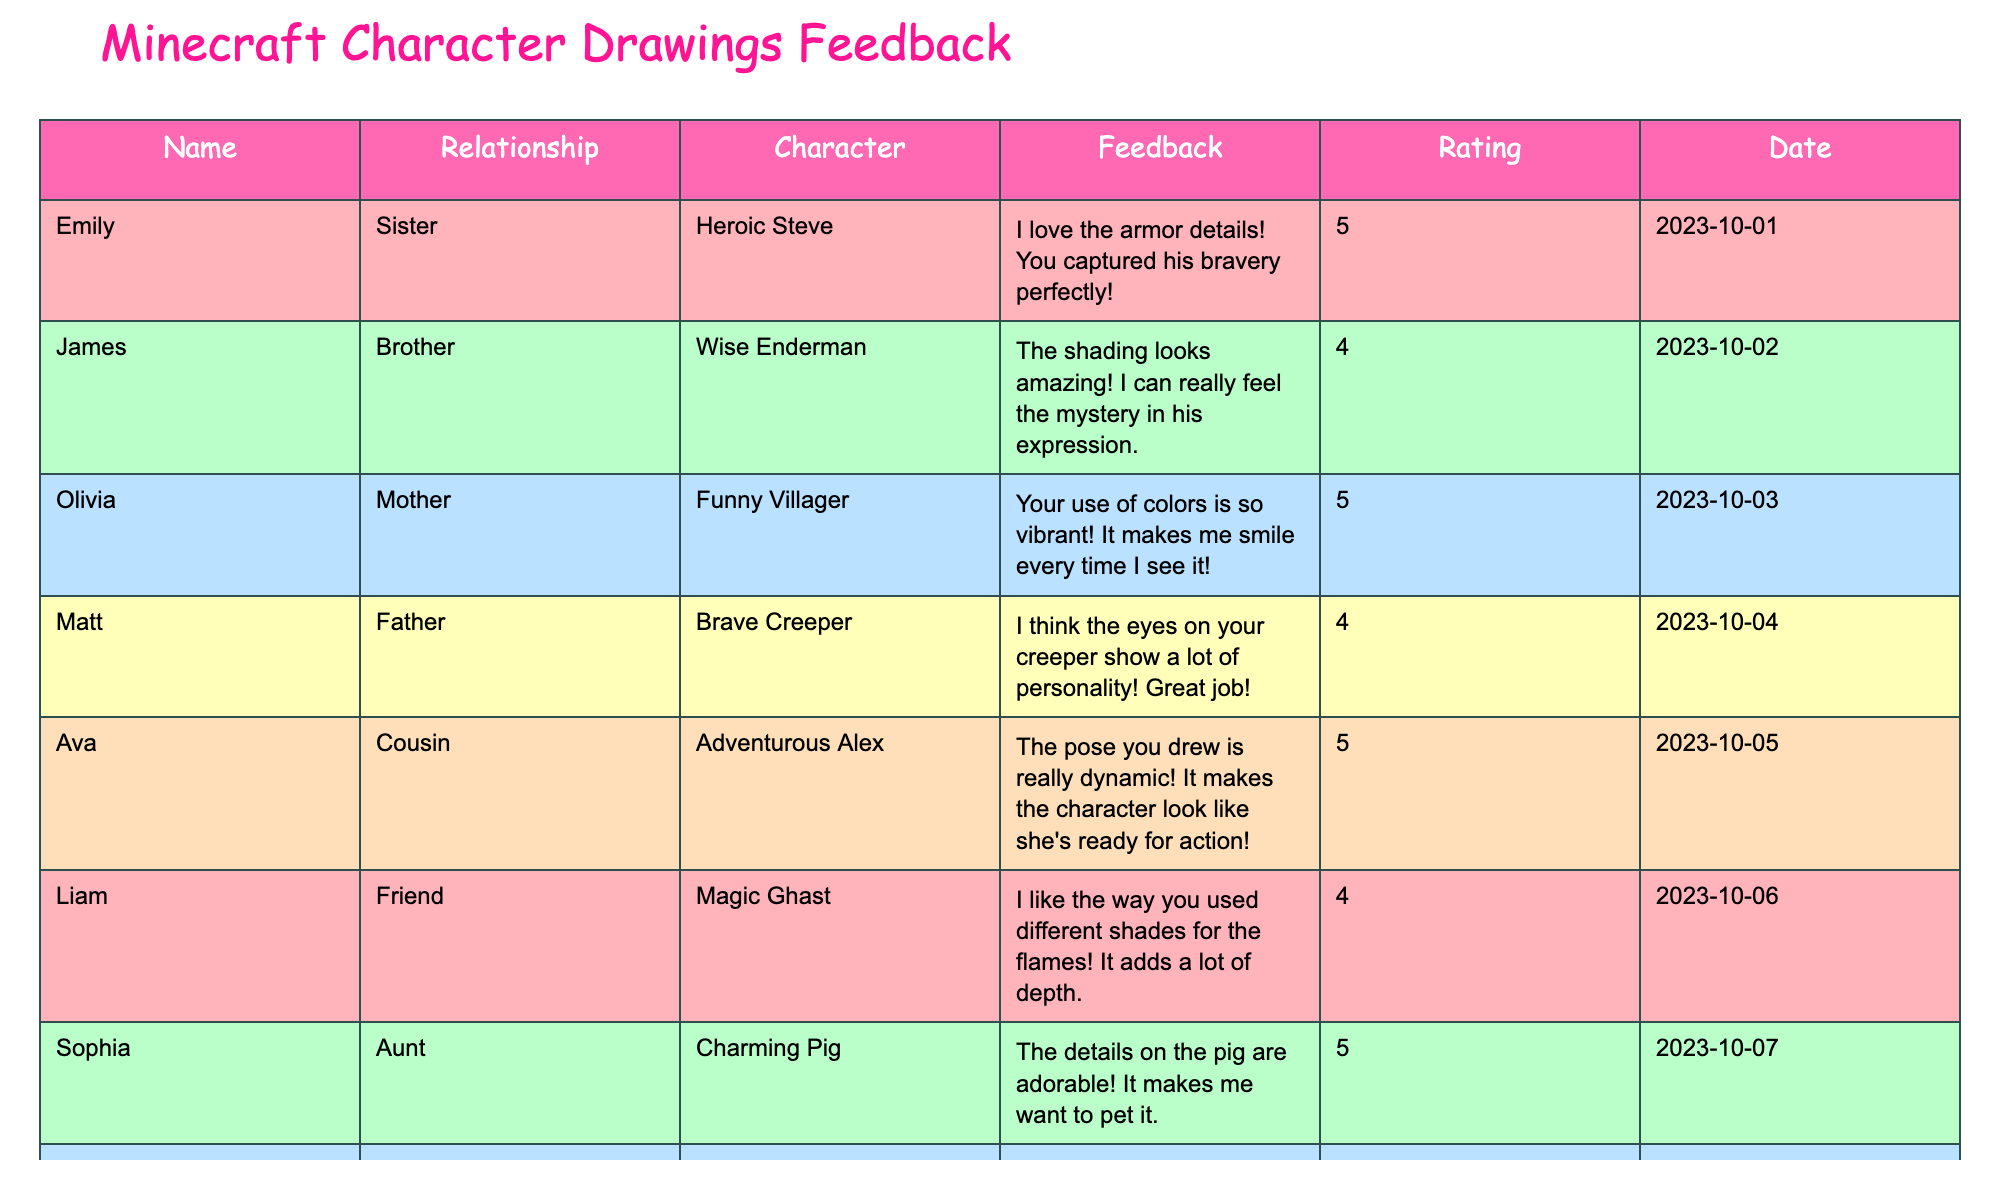What's the highest rating given for a character drawing? The ratings in the table show that "Heroic Steve," "Funny Villager," "Adventurous Alex," "Charming Pig," "Fast Skeleton," and "Playful Fox" all received the highest rating of 5.
Answer: 5 Who gave feedback for the character "Magic Ghast"? Looking through the table, it shows that Liam, a friend, provided feedback for the character "Magic Ghast."
Answer: Liam What is the average rating of all the character drawings? To find the average, add up all the ratings (5 + 4 + 5 + 4 + 5 + 4 + 5 + 4 + 5 + 5 = 50) and divide by the number of drawings (which is 10). Therefore, the average rating is 50 / 10 = 5.
Answer: 5 Did anyone rate "Brave Creeper" with a 5? A look at the feedback shows "Brave Creeper" received a rating of 4, so no one rated it with a 5.
Answer: No Which character has the feedback mentioning "shadows"? The feedback for "Stealthy Zombie" mentions the shadows, referring to the shadows around the zombie.
Answer: Stealthy Zombie How many characters received a rating of 4? Counting the ratings in the table, "Wise Enderman," "Brave Creeper," "Magic Ghast," and "Stealthy Zombie" received a rating of 4, which makes a total of 4 characters.
Answer: 4 What feedback did Noah give for "Stealthy Zombie"? Reviewing the table, Noah commented, "I love the shadows around the zombie! It gives off a cool nighttime vibe."
Answer: I love the shadows around the zombie! Which relationship gave the lowest feedback rating? The lowest rating of 4 is given by Matt (Father) for "Brave Creeper." Therefore, this is the lowest rating among all.
Answer: Matt (Father) What is the date when feedback for "Fast Skeleton" was given? The table indicates that feedback for "Fast Skeleton" was given on "2023-10-09."
Answer: 2023-10-09 Which character drew the most positive feedback? The table shows that "Heroic Steve," "Funny Villager," "Adventurous Alex," "Charming Pig," "Fast Skeleton," and "Playful Fox" all have the highest feedback rating of 5, making them the most positively received characters.
Answer: Heroic Steve, Funny Villager, Adventurous Alex, Charming Pig, Fast Skeleton, Playful Fox 